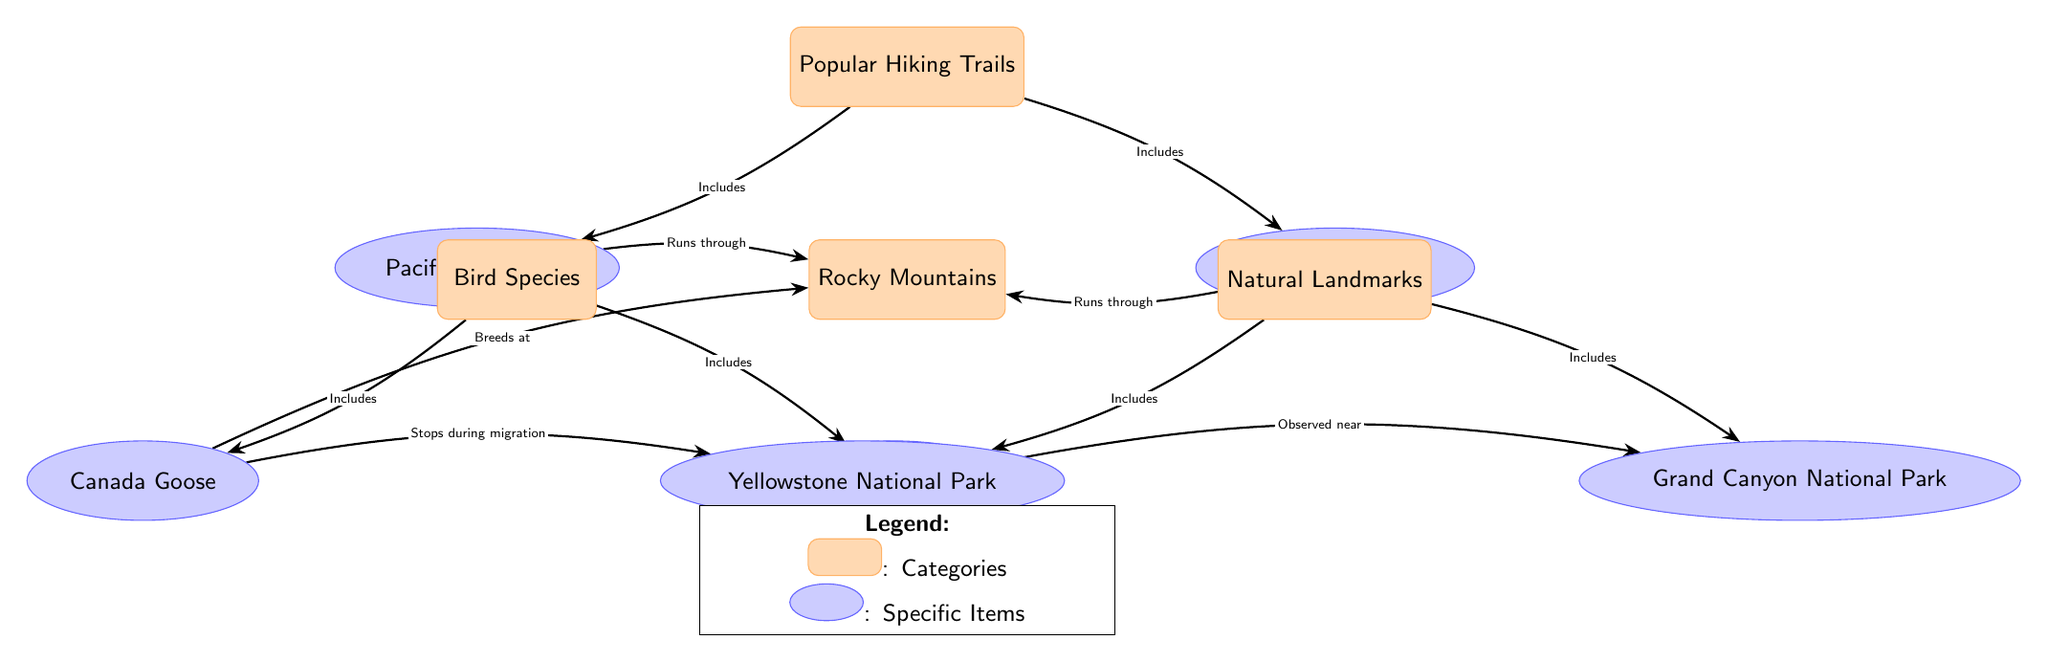What are the popular hiking trails listed in the diagram? The diagram presents two popular hiking trails: the Pacific Crest Trail and the Appalachian Trail, both categorized under "Popular Hiking Trails." These nodes are distinct items that fall under the category of hiking trails.
Answer: Pacific Crest Trail, Appalachian Trail How many bird species are included in the diagram? The diagram lists two specific bird species: the Canada Goose and the Common Loon, both categorized under "Bird Species." This count can be easily inferred from the number of item nodes connected to the bird species category.
Answer: 2 What natural landmark is associated with the Canada Goose? The Canada Goose is indicated to "Stop during migration" at Yellowstone National Park, connecting this bird species to that particular natural landmark in the diagram. The direct arrow illustrates this relationship clearly.
Answer: Yellowstone National Park Which hiking trail runs through the Rocky Mountains? Both the Pacific Crest Trail and the Appalachian Trail are shown to run through the Rocky Mountains, as indicated by the arrows connecting them to the Rocky Mountains category.
Answer: Pacific Crest Trail, Appalachian Trail How many items are included under the Natural Landmarks category? The Natural Landmarks category includes two items: Yellowstone National Park and Grand Canyon National Park. This can be determined by counting the item nodes listed under the natural landmarks category in the diagram.
Answer: 2 Which bird species is observed near the Grand Canyon National Park? The Common Loon is indicated to be "Observed near" the Grand Canyon National Park, as shown by the arrow pointing from the bird species to the natural landmark.
Answer: Common Loon What kinds of relationships exist between the Bird Species and Natural Landmarks? The relationships include: the Canada Goose breeds at the Rocky Mountains and stops during migration at Yellowstone National Park, while the Common Loon is observed near the Grand Canyon National Park. These relationships show where birds interact with specific natural landmarks.
Answer: Breeds, Stops, Observed How many arrows connect the trails to the Rocky Mountains? There are two arrows that connect the Popular Hiking Trails category to the Rocky Mountains, as both the Pacific Crest Trail and the Appalachian Trail are shown to run through it. This indicates two distinct relationships leading into the Rocky Mountains category.
Answer: 2 